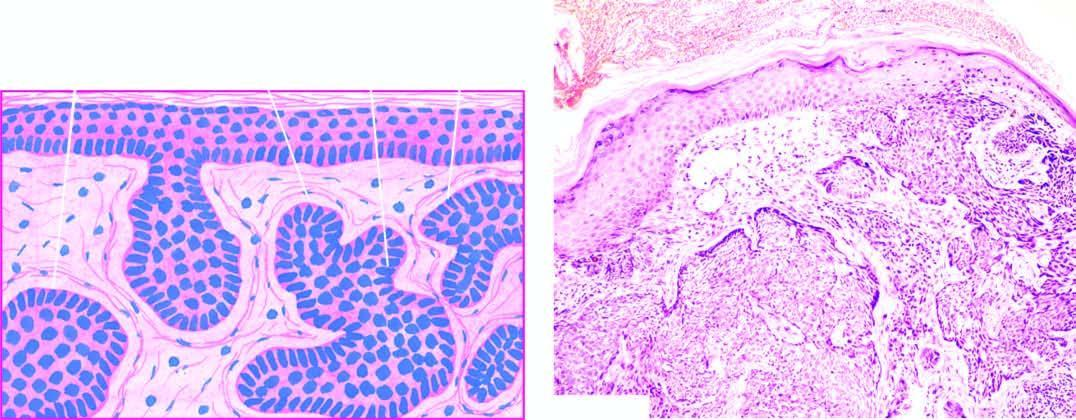what is invaded by irregular masses of basaloid cells with characteristic peripheral palisaded appearance?
Answer the question using a single word or phrase. Dermis 